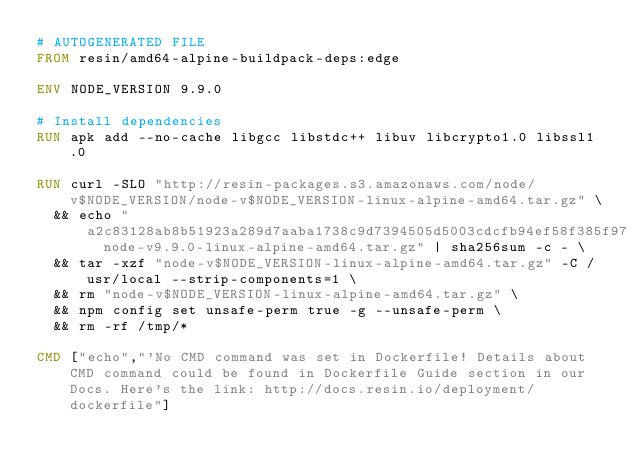Convert code to text. <code><loc_0><loc_0><loc_500><loc_500><_Dockerfile_># AUTOGENERATED FILE
FROM resin/amd64-alpine-buildpack-deps:edge

ENV NODE_VERSION 9.9.0

# Install dependencies
RUN apk add --no-cache libgcc libstdc++ libuv libcrypto1.0 libssl1.0

RUN curl -SLO "http://resin-packages.s3.amazonaws.com/node/v$NODE_VERSION/node-v$NODE_VERSION-linux-alpine-amd64.tar.gz" \
	&& echo "a2c83128ab8b51923a289d7aaba1738c9d7394505d5003cdcfb94ef58f385f97  node-v9.9.0-linux-alpine-amd64.tar.gz" | sha256sum -c - \
	&& tar -xzf "node-v$NODE_VERSION-linux-alpine-amd64.tar.gz" -C /usr/local --strip-components=1 \
	&& rm "node-v$NODE_VERSION-linux-alpine-amd64.tar.gz" \
	&& npm config set unsafe-perm true -g --unsafe-perm \
	&& rm -rf /tmp/*

CMD ["echo","'No CMD command was set in Dockerfile! Details about CMD command could be found in Dockerfile Guide section in our Docs. Here's the link: http://docs.resin.io/deployment/dockerfile"]
</code> 